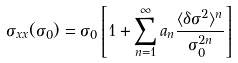<formula> <loc_0><loc_0><loc_500><loc_500>\sigma _ { x x } ( \sigma _ { 0 } ) = \sigma _ { 0 } \left [ 1 + \sum _ { n = 1 } ^ { \infty } a _ { n } \frac { \langle \delta \sigma ^ { 2 } \rangle ^ { n } } { \sigma _ { 0 } ^ { 2 n } } \right ]</formula> 